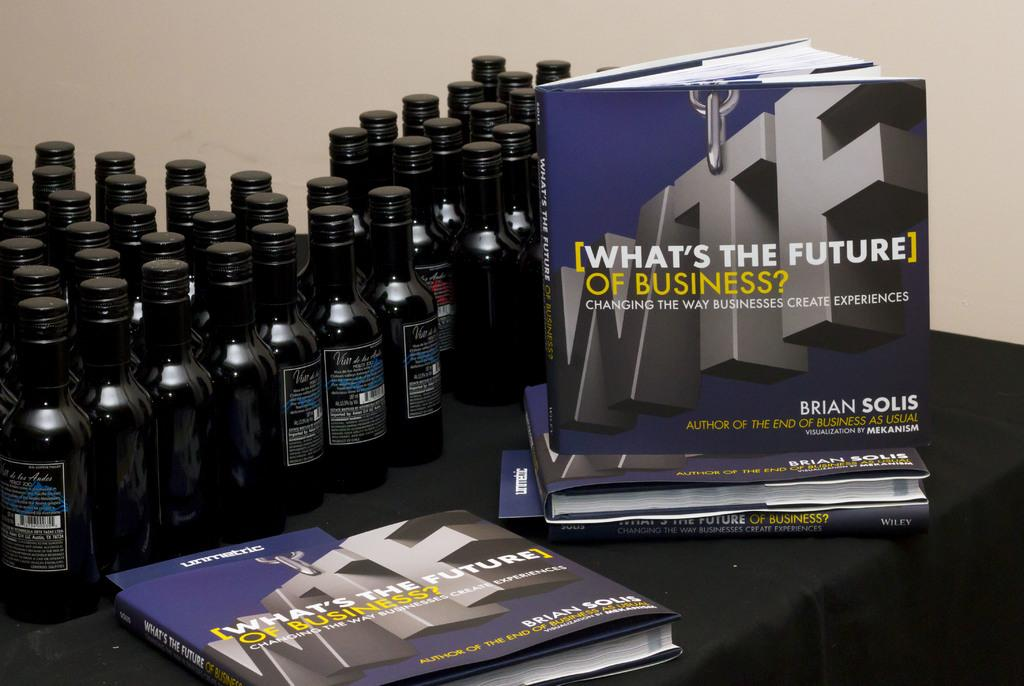<image>
Render a clear and concise summary of the photo. A book that is about the future of business resting on a table 